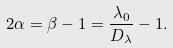<formula> <loc_0><loc_0><loc_500><loc_500>2 \alpha = \beta - 1 = \frac { \lambda _ { 0 } } { D _ { \lambda } } - 1 .</formula> 